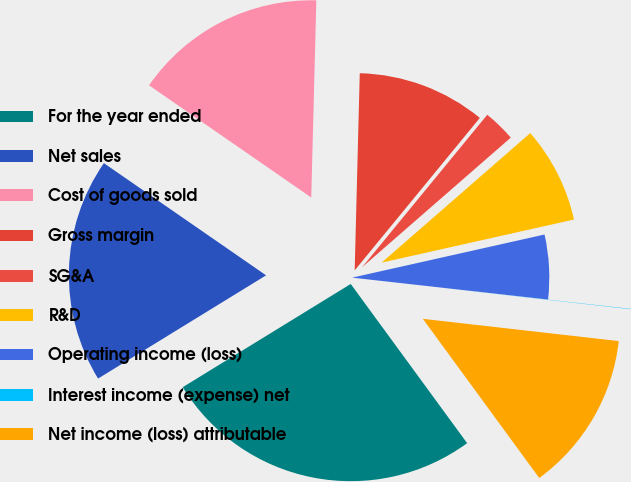Convert chart. <chart><loc_0><loc_0><loc_500><loc_500><pie_chart><fcel>For the year ended<fcel>Net sales<fcel>Cost of goods sold<fcel>Gross margin<fcel>SG&A<fcel>R&D<fcel>Operating income (loss)<fcel>Interest income (expense) net<fcel>Net income (loss) attributable<nl><fcel>26.28%<fcel>18.4%<fcel>15.78%<fcel>10.53%<fcel>2.65%<fcel>7.9%<fcel>5.28%<fcel>0.03%<fcel>13.15%<nl></chart> 